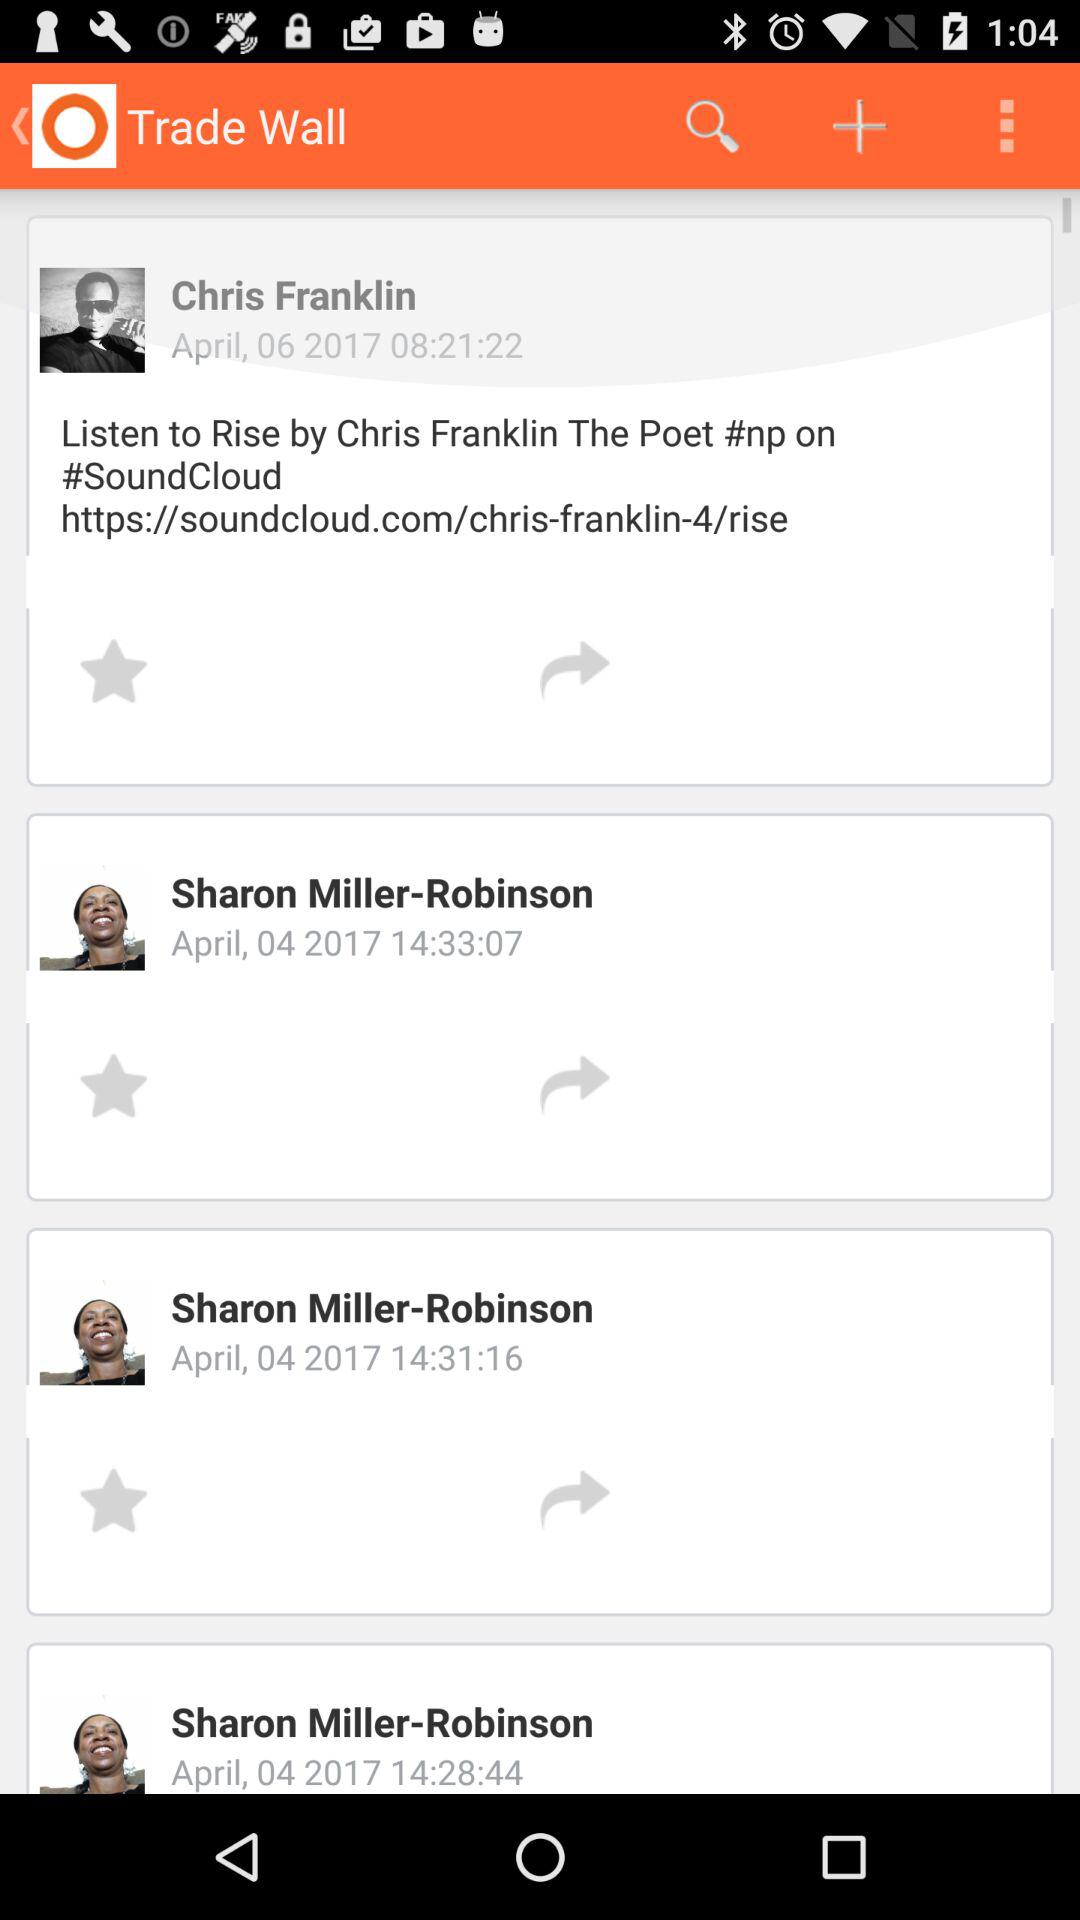At what time did Chris Franklin update the post? Chris Franklin updated the post on April 06, 2017. 